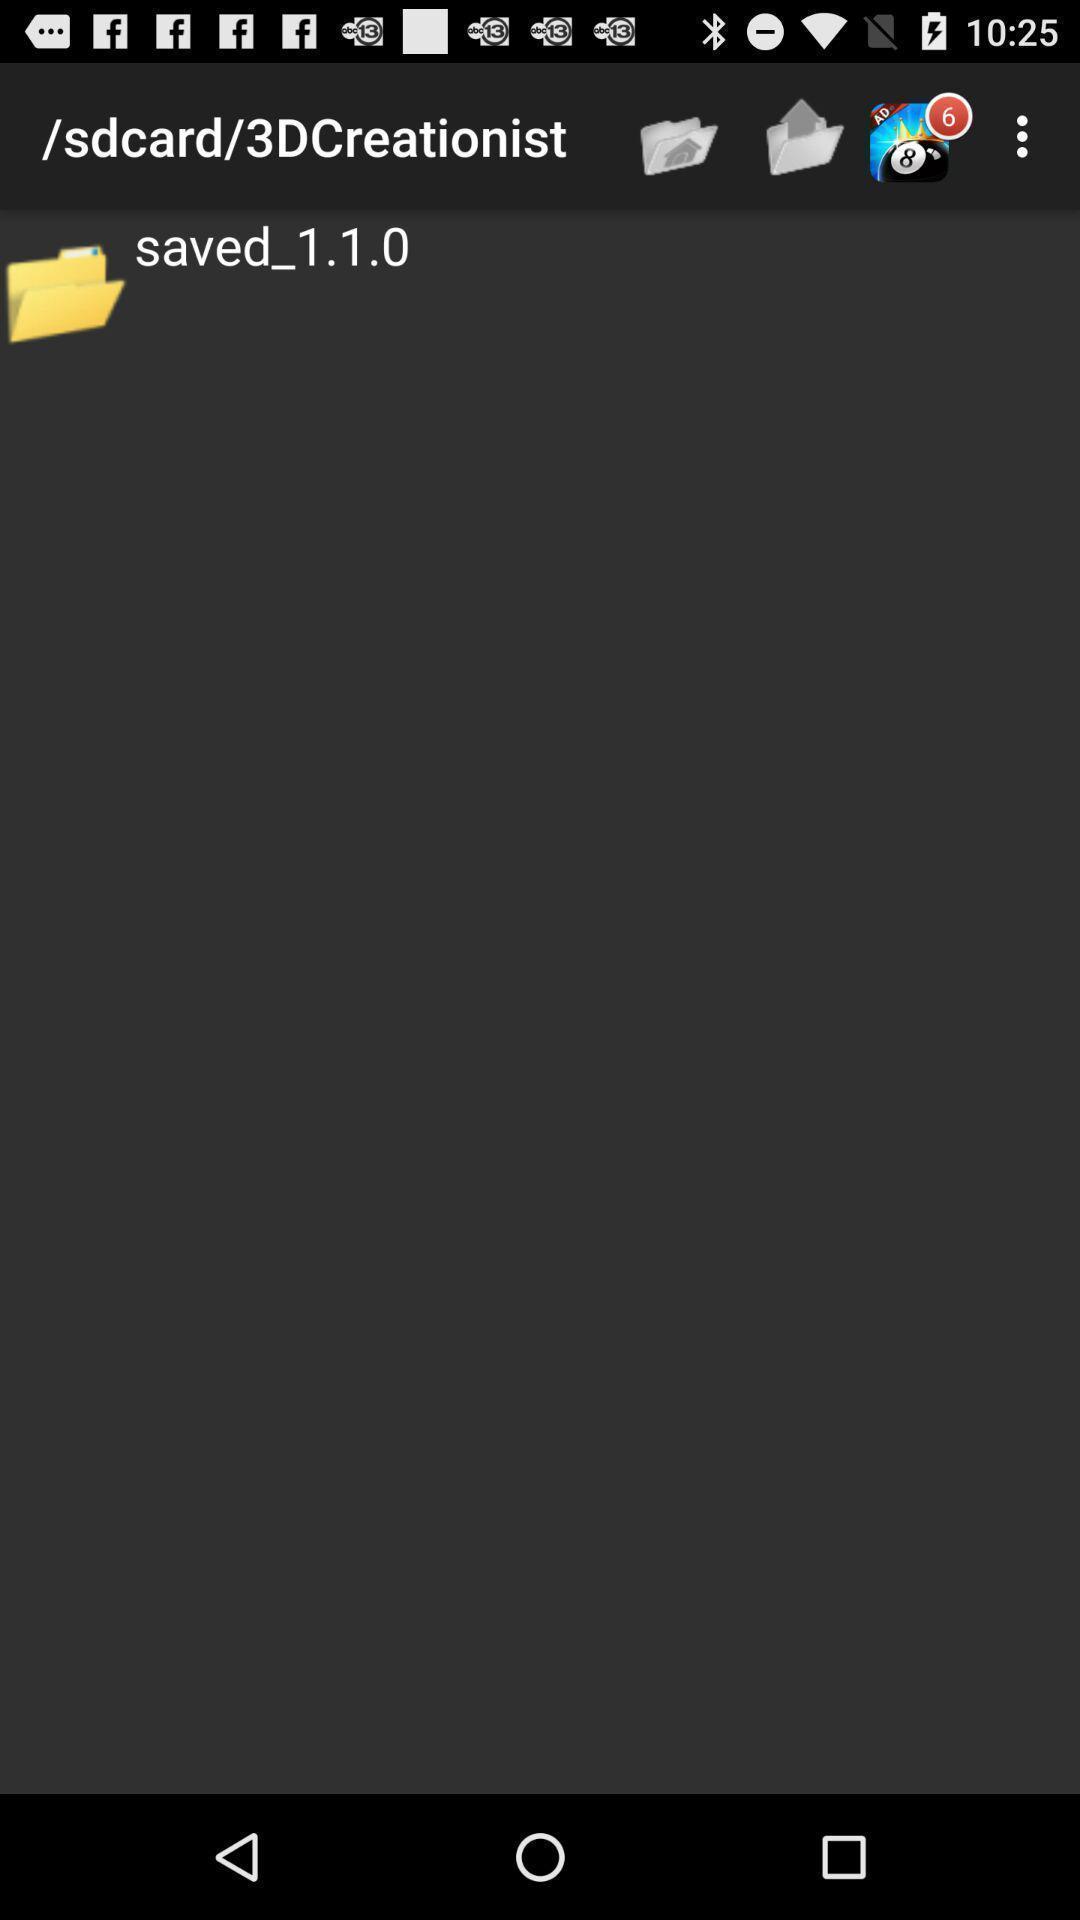Summarize the information in this screenshot. Page showing saved file in sd card. 